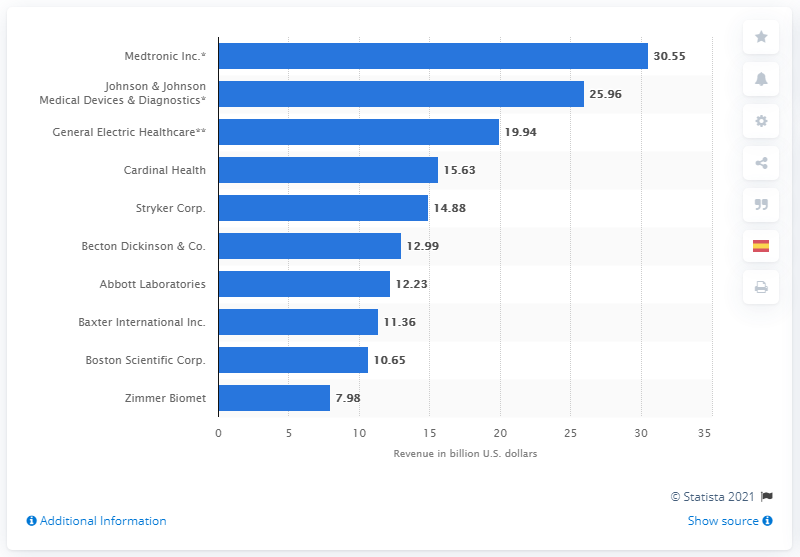Indicate a few pertinent items in this graphic. In 2019, Becton Dickinson & Co. generated approximately $12.99 billion in revenue. 